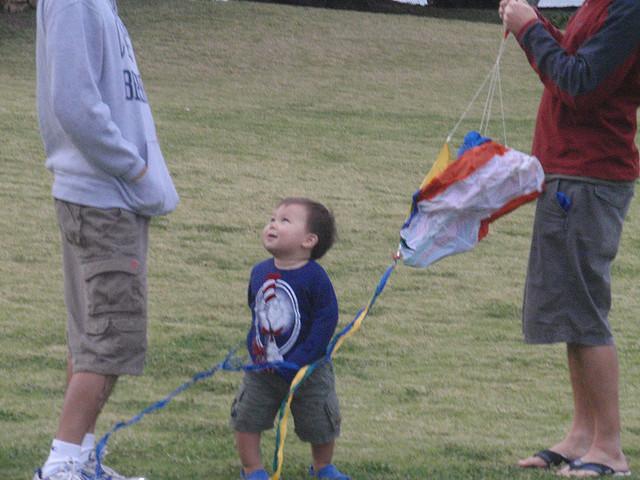What are they doing with the kite?
Quick response, please. Trying to fly it. How many adults are present?
Quick response, please. 2. What is the character on the child's shirt?
Answer briefly. Cat in hat. Are the boys under five years old?
Concise answer only. Yes. 